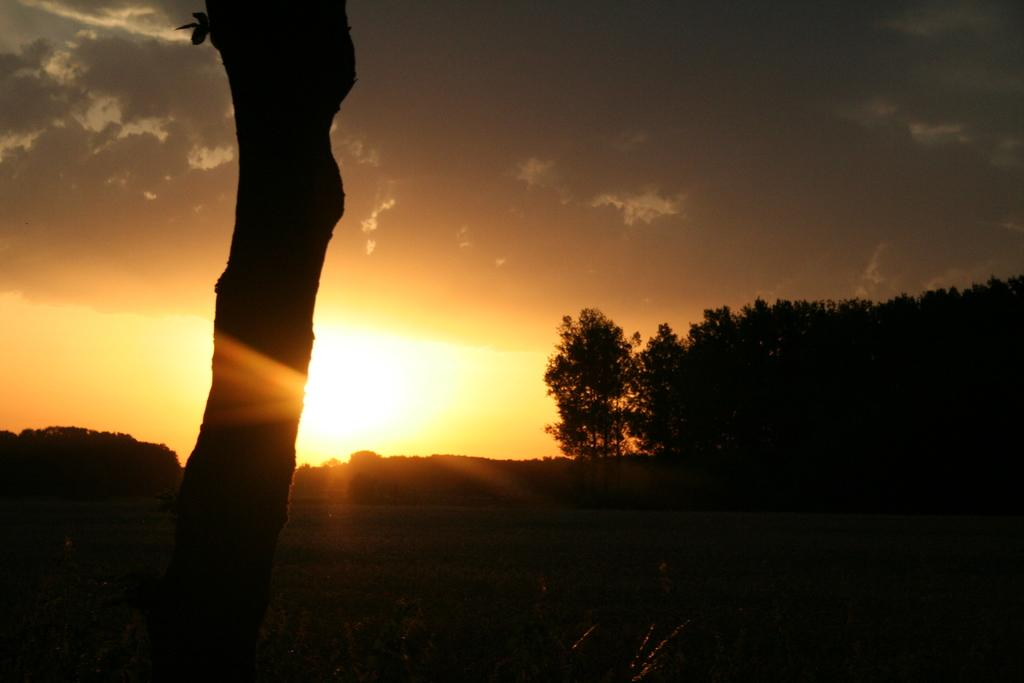What object is the main focus of the image? There is a trunk in the image. What can be seen in the background of the image? There are trees and the sun visible in the background of the image. What is the color of the sky in the image? The sky is gray in color. Can you see any ants crawling on the trunk in the image? There is no mention of ants in the image, so we cannot determine if any are present. Is there a fight happening between the trees in the background of the image? There is no indication of a fight or any conflict between the trees in the image. 